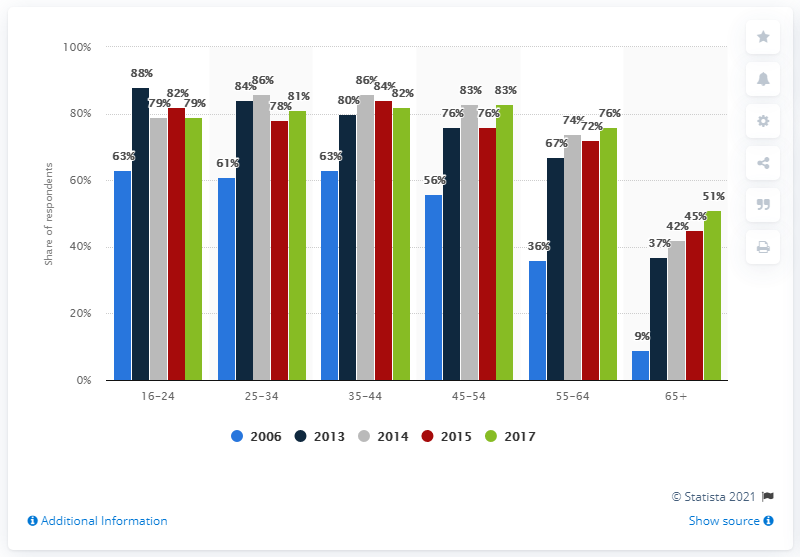Point out several critical features in this image. In 2017, computer usage in Great Britain increased by 79 percent from 2006, a significant increase that reflects the growing importance of technology in modern society. 